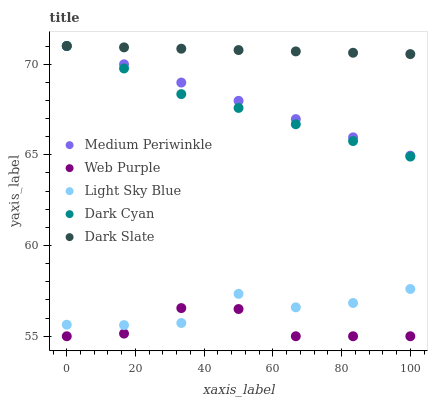Does Web Purple have the minimum area under the curve?
Answer yes or no. Yes. Does Dark Slate have the maximum area under the curve?
Answer yes or no. Yes. Does Dark Slate have the minimum area under the curve?
Answer yes or no. No. Does Web Purple have the maximum area under the curve?
Answer yes or no. No. Is Medium Periwinkle the smoothest?
Answer yes or no. Yes. Is Web Purple the roughest?
Answer yes or no. Yes. Is Dark Slate the smoothest?
Answer yes or no. No. Is Dark Slate the roughest?
Answer yes or no. No. Does Web Purple have the lowest value?
Answer yes or no. Yes. Does Dark Slate have the lowest value?
Answer yes or no. No. Does Medium Periwinkle have the highest value?
Answer yes or no. Yes. Does Web Purple have the highest value?
Answer yes or no. No. Is Web Purple less than Dark Cyan?
Answer yes or no. Yes. Is Dark Cyan greater than Light Sky Blue?
Answer yes or no. Yes. Does Dark Cyan intersect Medium Periwinkle?
Answer yes or no. Yes. Is Dark Cyan less than Medium Periwinkle?
Answer yes or no. No. Is Dark Cyan greater than Medium Periwinkle?
Answer yes or no. No. Does Web Purple intersect Dark Cyan?
Answer yes or no. No. 